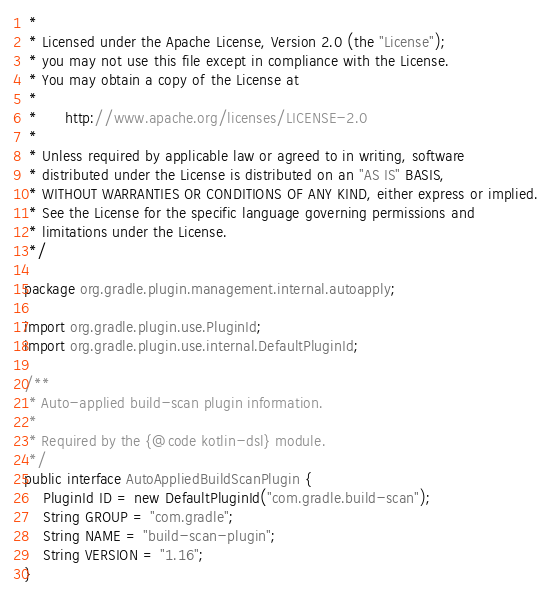<code> <loc_0><loc_0><loc_500><loc_500><_Java_> *
 * Licensed under the Apache License, Version 2.0 (the "License");
 * you may not use this file except in compliance with the License.
 * You may obtain a copy of the License at
 *
 *      http://www.apache.org/licenses/LICENSE-2.0
 *
 * Unless required by applicable law or agreed to in writing, software
 * distributed under the License is distributed on an "AS IS" BASIS,
 * WITHOUT WARRANTIES OR CONDITIONS OF ANY KIND, either express or implied.
 * See the License for the specific language governing permissions and
 * limitations under the License.
 */

package org.gradle.plugin.management.internal.autoapply;

import org.gradle.plugin.use.PluginId;
import org.gradle.plugin.use.internal.DefaultPluginId;

/**
 * Auto-applied build-scan plugin information.
 *
 * Required by the {@code kotlin-dsl} module.
 */
public interface AutoAppliedBuildScanPlugin {
    PluginId ID = new DefaultPluginId("com.gradle.build-scan");
    String GROUP = "com.gradle";
    String NAME = "build-scan-plugin";
    String VERSION = "1.16";
}
</code> 